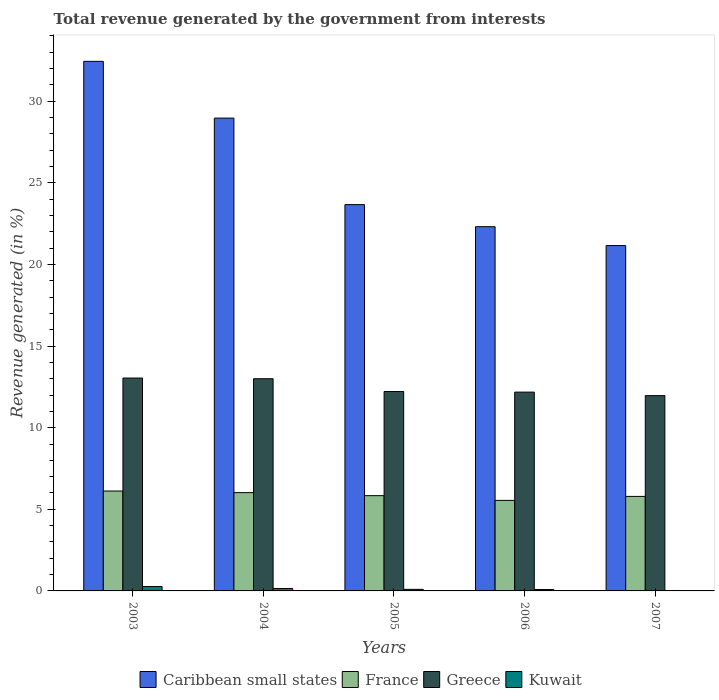How many different coloured bars are there?
Give a very brief answer. 4. How many groups of bars are there?
Provide a short and direct response. 5. Are the number of bars per tick equal to the number of legend labels?
Your response must be concise. Yes. Are the number of bars on each tick of the X-axis equal?
Provide a succinct answer. Yes. What is the label of the 1st group of bars from the left?
Ensure brevity in your answer.  2003. What is the total revenue generated in Greece in 2005?
Keep it short and to the point. 12.22. Across all years, what is the maximum total revenue generated in Caribbean small states?
Your answer should be very brief. 32.44. Across all years, what is the minimum total revenue generated in Caribbean small states?
Offer a very short reply. 21.16. What is the total total revenue generated in Kuwait in the graph?
Provide a short and direct response. 0.62. What is the difference between the total revenue generated in Greece in 2003 and that in 2004?
Keep it short and to the point. 0.04. What is the difference between the total revenue generated in France in 2003 and the total revenue generated in Greece in 2004?
Keep it short and to the point. -6.88. What is the average total revenue generated in Kuwait per year?
Keep it short and to the point. 0.12. In the year 2006, what is the difference between the total revenue generated in France and total revenue generated in Kuwait?
Provide a short and direct response. 5.46. What is the ratio of the total revenue generated in Greece in 2004 to that in 2006?
Provide a short and direct response. 1.07. Is the total revenue generated in Kuwait in 2004 less than that in 2006?
Give a very brief answer. No. Is the difference between the total revenue generated in France in 2004 and 2005 greater than the difference between the total revenue generated in Kuwait in 2004 and 2005?
Your response must be concise. Yes. What is the difference between the highest and the second highest total revenue generated in Kuwait?
Provide a short and direct response. 0.12. What is the difference between the highest and the lowest total revenue generated in France?
Your answer should be very brief. 0.57. In how many years, is the total revenue generated in Kuwait greater than the average total revenue generated in Kuwait taken over all years?
Your answer should be compact. 2. Is the sum of the total revenue generated in Greece in 2006 and 2007 greater than the maximum total revenue generated in France across all years?
Ensure brevity in your answer.  Yes. What does the 4th bar from the left in 2006 represents?
Provide a short and direct response. Kuwait. What does the 1st bar from the right in 2004 represents?
Your response must be concise. Kuwait. Is it the case that in every year, the sum of the total revenue generated in Greece and total revenue generated in France is greater than the total revenue generated in Kuwait?
Offer a terse response. Yes. Are all the bars in the graph horizontal?
Provide a succinct answer. No. What is the difference between two consecutive major ticks on the Y-axis?
Offer a very short reply. 5. Are the values on the major ticks of Y-axis written in scientific E-notation?
Keep it short and to the point. No. Does the graph contain any zero values?
Ensure brevity in your answer.  No. Does the graph contain grids?
Your answer should be very brief. No. Where does the legend appear in the graph?
Your response must be concise. Bottom center. How many legend labels are there?
Offer a very short reply. 4. What is the title of the graph?
Your answer should be compact. Total revenue generated by the government from interests. What is the label or title of the Y-axis?
Offer a terse response. Revenue generated (in %). What is the Revenue generated (in %) in Caribbean small states in 2003?
Your response must be concise. 32.44. What is the Revenue generated (in %) in France in 2003?
Provide a short and direct response. 6.12. What is the Revenue generated (in %) in Greece in 2003?
Keep it short and to the point. 13.04. What is the Revenue generated (in %) of Kuwait in 2003?
Provide a short and direct response. 0.27. What is the Revenue generated (in %) of Caribbean small states in 2004?
Offer a very short reply. 28.97. What is the Revenue generated (in %) in France in 2004?
Give a very brief answer. 6.02. What is the Revenue generated (in %) in Greece in 2004?
Your response must be concise. 13. What is the Revenue generated (in %) in Kuwait in 2004?
Provide a succinct answer. 0.15. What is the Revenue generated (in %) of Caribbean small states in 2005?
Make the answer very short. 23.67. What is the Revenue generated (in %) of France in 2005?
Provide a succinct answer. 5.84. What is the Revenue generated (in %) of Greece in 2005?
Offer a terse response. 12.22. What is the Revenue generated (in %) in Kuwait in 2005?
Ensure brevity in your answer.  0.1. What is the Revenue generated (in %) of Caribbean small states in 2006?
Provide a succinct answer. 22.31. What is the Revenue generated (in %) of France in 2006?
Your response must be concise. 5.55. What is the Revenue generated (in %) in Greece in 2006?
Keep it short and to the point. 12.18. What is the Revenue generated (in %) of Kuwait in 2006?
Offer a very short reply. 0.08. What is the Revenue generated (in %) of Caribbean small states in 2007?
Provide a succinct answer. 21.16. What is the Revenue generated (in %) in France in 2007?
Keep it short and to the point. 5.79. What is the Revenue generated (in %) in Greece in 2007?
Give a very brief answer. 11.96. What is the Revenue generated (in %) of Kuwait in 2007?
Make the answer very short. 0.03. Across all years, what is the maximum Revenue generated (in %) in Caribbean small states?
Your response must be concise. 32.44. Across all years, what is the maximum Revenue generated (in %) of France?
Your response must be concise. 6.12. Across all years, what is the maximum Revenue generated (in %) in Greece?
Provide a succinct answer. 13.04. Across all years, what is the maximum Revenue generated (in %) of Kuwait?
Your answer should be very brief. 0.27. Across all years, what is the minimum Revenue generated (in %) of Caribbean small states?
Provide a short and direct response. 21.16. Across all years, what is the minimum Revenue generated (in %) of France?
Keep it short and to the point. 5.55. Across all years, what is the minimum Revenue generated (in %) in Greece?
Keep it short and to the point. 11.96. Across all years, what is the minimum Revenue generated (in %) in Kuwait?
Provide a succinct answer. 0.03. What is the total Revenue generated (in %) in Caribbean small states in the graph?
Your response must be concise. 128.54. What is the total Revenue generated (in %) of France in the graph?
Your response must be concise. 29.31. What is the total Revenue generated (in %) of Greece in the graph?
Your response must be concise. 62.4. What is the total Revenue generated (in %) of Kuwait in the graph?
Keep it short and to the point. 0.62. What is the difference between the Revenue generated (in %) of Caribbean small states in 2003 and that in 2004?
Ensure brevity in your answer.  3.48. What is the difference between the Revenue generated (in %) in France in 2003 and that in 2004?
Offer a very short reply. 0.1. What is the difference between the Revenue generated (in %) in Greece in 2003 and that in 2004?
Your answer should be very brief. 0.04. What is the difference between the Revenue generated (in %) in Kuwait in 2003 and that in 2004?
Ensure brevity in your answer.  0.12. What is the difference between the Revenue generated (in %) of Caribbean small states in 2003 and that in 2005?
Offer a very short reply. 8.78. What is the difference between the Revenue generated (in %) of France in 2003 and that in 2005?
Make the answer very short. 0.28. What is the difference between the Revenue generated (in %) of Greece in 2003 and that in 2005?
Your answer should be very brief. 0.83. What is the difference between the Revenue generated (in %) of Kuwait in 2003 and that in 2005?
Your answer should be very brief. 0.17. What is the difference between the Revenue generated (in %) of Caribbean small states in 2003 and that in 2006?
Ensure brevity in your answer.  10.13. What is the difference between the Revenue generated (in %) of France in 2003 and that in 2006?
Keep it short and to the point. 0.57. What is the difference between the Revenue generated (in %) in Greece in 2003 and that in 2006?
Give a very brief answer. 0.86. What is the difference between the Revenue generated (in %) in Kuwait in 2003 and that in 2006?
Your response must be concise. 0.18. What is the difference between the Revenue generated (in %) in Caribbean small states in 2003 and that in 2007?
Your response must be concise. 11.29. What is the difference between the Revenue generated (in %) in France in 2003 and that in 2007?
Provide a succinct answer. 0.33. What is the difference between the Revenue generated (in %) of Greece in 2003 and that in 2007?
Your response must be concise. 1.08. What is the difference between the Revenue generated (in %) of Kuwait in 2003 and that in 2007?
Your response must be concise. 0.24. What is the difference between the Revenue generated (in %) in Caribbean small states in 2004 and that in 2005?
Give a very brief answer. 5.3. What is the difference between the Revenue generated (in %) of France in 2004 and that in 2005?
Keep it short and to the point. 0.19. What is the difference between the Revenue generated (in %) of Greece in 2004 and that in 2005?
Your response must be concise. 0.78. What is the difference between the Revenue generated (in %) in Kuwait in 2004 and that in 2005?
Keep it short and to the point. 0.05. What is the difference between the Revenue generated (in %) of Caribbean small states in 2004 and that in 2006?
Offer a very short reply. 6.65. What is the difference between the Revenue generated (in %) of France in 2004 and that in 2006?
Provide a short and direct response. 0.48. What is the difference between the Revenue generated (in %) of Greece in 2004 and that in 2006?
Your response must be concise. 0.82. What is the difference between the Revenue generated (in %) in Kuwait in 2004 and that in 2006?
Ensure brevity in your answer.  0.06. What is the difference between the Revenue generated (in %) of Caribbean small states in 2004 and that in 2007?
Provide a short and direct response. 7.81. What is the difference between the Revenue generated (in %) of France in 2004 and that in 2007?
Offer a terse response. 0.23. What is the difference between the Revenue generated (in %) in Greece in 2004 and that in 2007?
Your response must be concise. 1.04. What is the difference between the Revenue generated (in %) in Kuwait in 2004 and that in 2007?
Give a very brief answer. 0.12. What is the difference between the Revenue generated (in %) in Caribbean small states in 2005 and that in 2006?
Offer a terse response. 1.35. What is the difference between the Revenue generated (in %) in France in 2005 and that in 2006?
Give a very brief answer. 0.29. What is the difference between the Revenue generated (in %) of Greece in 2005 and that in 2006?
Your answer should be very brief. 0.04. What is the difference between the Revenue generated (in %) of Kuwait in 2005 and that in 2006?
Provide a short and direct response. 0.01. What is the difference between the Revenue generated (in %) of Caribbean small states in 2005 and that in 2007?
Make the answer very short. 2.51. What is the difference between the Revenue generated (in %) in France in 2005 and that in 2007?
Your answer should be very brief. 0.04. What is the difference between the Revenue generated (in %) in Greece in 2005 and that in 2007?
Provide a short and direct response. 0.25. What is the difference between the Revenue generated (in %) of Kuwait in 2005 and that in 2007?
Your answer should be compact. 0.07. What is the difference between the Revenue generated (in %) in Caribbean small states in 2006 and that in 2007?
Provide a succinct answer. 1.16. What is the difference between the Revenue generated (in %) in France in 2006 and that in 2007?
Give a very brief answer. -0.24. What is the difference between the Revenue generated (in %) of Greece in 2006 and that in 2007?
Your answer should be compact. 0.21. What is the difference between the Revenue generated (in %) of Kuwait in 2006 and that in 2007?
Give a very brief answer. 0.06. What is the difference between the Revenue generated (in %) in Caribbean small states in 2003 and the Revenue generated (in %) in France in 2004?
Provide a succinct answer. 26.42. What is the difference between the Revenue generated (in %) of Caribbean small states in 2003 and the Revenue generated (in %) of Greece in 2004?
Provide a short and direct response. 19.44. What is the difference between the Revenue generated (in %) of Caribbean small states in 2003 and the Revenue generated (in %) of Kuwait in 2004?
Your answer should be very brief. 32.29. What is the difference between the Revenue generated (in %) of France in 2003 and the Revenue generated (in %) of Greece in 2004?
Your answer should be very brief. -6.88. What is the difference between the Revenue generated (in %) in France in 2003 and the Revenue generated (in %) in Kuwait in 2004?
Make the answer very short. 5.97. What is the difference between the Revenue generated (in %) of Greece in 2003 and the Revenue generated (in %) of Kuwait in 2004?
Make the answer very short. 12.89. What is the difference between the Revenue generated (in %) in Caribbean small states in 2003 and the Revenue generated (in %) in France in 2005?
Your answer should be compact. 26.61. What is the difference between the Revenue generated (in %) of Caribbean small states in 2003 and the Revenue generated (in %) of Greece in 2005?
Offer a terse response. 20.23. What is the difference between the Revenue generated (in %) in Caribbean small states in 2003 and the Revenue generated (in %) in Kuwait in 2005?
Your answer should be very brief. 32.35. What is the difference between the Revenue generated (in %) in France in 2003 and the Revenue generated (in %) in Greece in 2005?
Provide a succinct answer. -6.09. What is the difference between the Revenue generated (in %) of France in 2003 and the Revenue generated (in %) of Kuwait in 2005?
Your response must be concise. 6.02. What is the difference between the Revenue generated (in %) of Greece in 2003 and the Revenue generated (in %) of Kuwait in 2005?
Offer a very short reply. 12.95. What is the difference between the Revenue generated (in %) of Caribbean small states in 2003 and the Revenue generated (in %) of France in 2006?
Your answer should be very brief. 26.9. What is the difference between the Revenue generated (in %) of Caribbean small states in 2003 and the Revenue generated (in %) of Greece in 2006?
Keep it short and to the point. 20.26. What is the difference between the Revenue generated (in %) of Caribbean small states in 2003 and the Revenue generated (in %) of Kuwait in 2006?
Provide a succinct answer. 32.36. What is the difference between the Revenue generated (in %) in France in 2003 and the Revenue generated (in %) in Greece in 2006?
Your answer should be compact. -6.06. What is the difference between the Revenue generated (in %) in France in 2003 and the Revenue generated (in %) in Kuwait in 2006?
Your answer should be very brief. 6.04. What is the difference between the Revenue generated (in %) of Greece in 2003 and the Revenue generated (in %) of Kuwait in 2006?
Provide a succinct answer. 12.96. What is the difference between the Revenue generated (in %) in Caribbean small states in 2003 and the Revenue generated (in %) in France in 2007?
Your response must be concise. 26.65. What is the difference between the Revenue generated (in %) in Caribbean small states in 2003 and the Revenue generated (in %) in Greece in 2007?
Ensure brevity in your answer.  20.48. What is the difference between the Revenue generated (in %) of Caribbean small states in 2003 and the Revenue generated (in %) of Kuwait in 2007?
Offer a very short reply. 32.42. What is the difference between the Revenue generated (in %) of France in 2003 and the Revenue generated (in %) of Greece in 2007?
Your answer should be very brief. -5.84. What is the difference between the Revenue generated (in %) in France in 2003 and the Revenue generated (in %) in Kuwait in 2007?
Give a very brief answer. 6.09. What is the difference between the Revenue generated (in %) in Greece in 2003 and the Revenue generated (in %) in Kuwait in 2007?
Provide a short and direct response. 13.01. What is the difference between the Revenue generated (in %) in Caribbean small states in 2004 and the Revenue generated (in %) in France in 2005?
Your answer should be very brief. 23.13. What is the difference between the Revenue generated (in %) of Caribbean small states in 2004 and the Revenue generated (in %) of Greece in 2005?
Ensure brevity in your answer.  16.75. What is the difference between the Revenue generated (in %) in Caribbean small states in 2004 and the Revenue generated (in %) in Kuwait in 2005?
Your answer should be very brief. 28.87. What is the difference between the Revenue generated (in %) in France in 2004 and the Revenue generated (in %) in Greece in 2005?
Your response must be concise. -6.19. What is the difference between the Revenue generated (in %) in France in 2004 and the Revenue generated (in %) in Kuwait in 2005?
Offer a terse response. 5.93. What is the difference between the Revenue generated (in %) of Greece in 2004 and the Revenue generated (in %) of Kuwait in 2005?
Keep it short and to the point. 12.9. What is the difference between the Revenue generated (in %) of Caribbean small states in 2004 and the Revenue generated (in %) of France in 2006?
Your answer should be very brief. 23.42. What is the difference between the Revenue generated (in %) in Caribbean small states in 2004 and the Revenue generated (in %) in Greece in 2006?
Ensure brevity in your answer.  16.79. What is the difference between the Revenue generated (in %) in Caribbean small states in 2004 and the Revenue generated (in %) in Kuwait in 2006?
Make the answer very short. 28.88. What is the difference between the Revenue generated (in %) in France in 2004 and the Revenue generated (in %) in Greece in 2006?
Ensure brevity in your answer.  -6.16. What is the difference between the Revenue generated (in %) of France in 2004 and the Revenue generated (in %) of Kuwait in 2006?
Give a very brief answer. 5.94. What is the difference between the Revenue generated (in %) in Greece in 2004 and the Revenue generated (in %) in Kuwait in 2006?
Keep it short and to the point. 12.91. What is the difference between the Revenue generated (in %) in Caribbean small states in 2004 and the Revenue generated (in %) in France in 2007?
Ensure brevity in your answer.  23.17. What is the difference between the Revenue generated (in %) in Caribbean small states in 2004 and the Revenue generated (in %) in Greece in 2007?
Provide a succinct answer. 17. What is the difference between the Revenue generated (in %) of Caribbean small states in 2004 and the Revenue generated (in %) of Kuwait in 2007?
Provide a short and direct response. 28.94. What is the difference between the Revenue generated (in %) in France in 2004 and the Revenue generated (in %) in Greece in 2007?
Your answer should be very brief. -5.94. What is the difference between the Revenue generated (in %) in France in 2004 and the Revenue generated (in %) in Kuwait in 2007?
Ensure brevity in your answer.  6. What is the difference between the Revenue generated (in %) in Greece in 2004 and the Revenue generated (in %) in Kuwait in 2007?
Give a very brief answer. 12.97. What is the difference between the Revenue generated (in %) in Caribbean small states in 2005 and the Revenue generated (in %) in France in 2006?
Keep it short and to the point. 18.12. What is the difference between the Revenue generated (in %) in Caribbean small states in 2005 and the Revenue generated (in %) in Greece in 2006?
Your response must be concise. 11.49. What is the difference between the Revenue generated (in %) in Caribbean small states in 2005 and the Revenue generated (in %) in Kuwait in 2006?
Offer a very short reply. 23.58. What is the difference between the Revenue generated (in %) in France in 2005 and the Revenue generated (in %) in Greece in 2006?
Offer a very short reply. -6.34. What is the difference between the Revenue generated (in %) in France in 2005 and the Revenue generated (in %) in Kuwait in 2006?
Your answer should be compact. 5.75. What is the difference between the Revenue generated (in %) in Greece in 2005 and the Revenue generated (in %) in Kuwait in 2006?
Keep it short and to the point. 12.13. What is the difference between the Revenue generated (in %) in Caribbean small states in 2005 and the Revenue generated (in %) in France in 2007?
Provide a short and direct response. 17.87. What is the difference between the Revenue generated (in %) in Caribbean small states in 2005 and the Revenue generated (in %) in Greece in 2007?
Keep it short and to the point. 11.7. What is the difference between the Revenue generated (in %) in Caribbean small states in 2005 and the Revenue generated (in %) in Kuwait in 2007?
Ensure brevity in your answer.  23.64. What is the difference between the Revenue generated (in %) in France in 2005 and the Revenue generated (in %) in Greece in 2007?
Provide a succinct answer. -6.13. What is the difference between the Revenue generated (in %) of France in 2005 and the Revenue generated (in %) of Kuwait in 2007?
Your response must be concise. 5.81. What is the difference between the Revenue generated (in %) of Greece in 2005 and the Revenue generated (in %) of Kuwait in 2007?
Keep it short and to the point. 12.19. What is the difference between the Revenue generated (in %) of Caribbean small states in 2006 and the Revenue generated (in %) of France in 2007?
Your answer should be very brief. 16.52. What is the difference between the Revenue generated (in %) of Caribbean small states in 2006 and the Revenue generated (in %) of Greece in 2007?
Give a very brief answer. 10.35. What is the difference between the Revenue generated (in %) of Caribbean small states in 2006 and the Revenue generated (in %) of Kuwait in 2007?
Provide a succinct answer. 22.29. What is the difference between the Revenue generated (in %) in France in 2006 and the Revenue generated (in %) in Greece in 2007?
Offer a terse response. -6.42. What is the difference between the Revenue generated (in %) in France in 2006 and the Revenue generated (in %) in Kuwait in 2007?
Your response must be concise. 5.52. What is the difference between the Revenue generated (in %) in Greece in 2006 and the Revenue generated (in %) in Kuwait in 2007?
Make the answer very short. 12.15. What is the average Revenue generated (in %) in Caribbean small states per year?
Provide a succinct answer. 25.71. What is the average Revenue generated (in %) of France per year?
Ensure brevity in your answer.  5.86. What is the average Revenue generated (in %) in Greece per year?
Provide a short and direct response. 12.48. What is the average Revenue generated (in %) in Kuwait per year?
Provide a succinct answer. 0.12. In the year 2003, what is the difference between the Revenue generated (in %) in Caribbean small states and Revenue generated (in %) in France?
Ensure brevity in your answer.  26.32. In the year 2003, what is the difference between the Revenue generated (in %) in Caribbean small states and Revenue generated (in %) in Greece?
Make the answer very short. 19.4. In the year 2003, what is the difference between the Revenue generated (in %) of Caribbean small states and Revenue generated (in %) of Kuwait?
Provide a succinct answer. 32.17. In the year 2003, what is the difference between the Revenue generated (in %) in France and Revenue generated (in %) in Greece?
Offer a terse response. -6.92. In the year 2003, what is the difference between the Revenue generated (in %) in France and Revenue generated (in %) in Kuwait?
Offer a very short reply. 5.85. In the year 2003, what is the difference between the Revenue generated (in %) of Greece and Revenue generated (in %) of Kuwait?
Provide a succinct answer. 12.77. In the year 2004, what is the difference between the Revenue generated (in %) of Caribbean small states and Revenue generated (in %) of France?
Keep it short and to the point. 22.94. In the year 2004, what is the difference between the Revenue generated (in %) in Caribbean small states and Revenue generated (in %) in Greece?
Offer a very short reply. 15.97. In the year 2004, what is the difference between the Revenue generated (in %) in Caribbean small states and Revenue generated (in %) in Kuwait?
Keep it short and to the point. 28.82. In the year 2004, what is the difference between the Revenue generated (in %) of France and Revenue generated (in %) of Greece?
Provide a succinct answer. -6.98. In the year 2004, what is the difference between the Revenue generated (in %) of France and Revenue generated (in %) of Kuwait?
Offer a terse response. 5.87. In the year 2004, what is the difference between the Revenue generated (in %) of Greece and Revenue generated (in %) of Kuwait?
Your response must be concise. 12.85. In the year 2005, what is the difference between the Revenue generated (in %) in Caribbean small states and Revenue generated (in %) in France?
Provide a short and direct response. 17.83. In the year 2005, what is the difference between the Revenue generated (in %) in Caribbean small states and Revenue generated (in %) in Greece?
Give a very brief answer. 11.45. In the year 2005, what is the difference between the Revenue generated (in %) in Caribbean small states and Revenue generated (in %) in Kuwait?
Make the answer very short. 23.57. In the year 2005, what is the difference between the Revenue generated (in %) of France and Revenue generated (in %) of Greece?
Offer a very short reply. -6.38. In the year 2005, what is the difference between the Revenue generated (in %) of France and Revenue generated (in %) of Kuwait?
Keep it short and to the point. 5.74. In the year 2005, what is the difference between the Revenue generated (in %) of Greece and Revenue generated (in %) of Kuwait?
Provide a short and direct response. 12.12. In the year 2006, what is the difference between the Revenue generated (in %) of Caribbean small states and Revenue generated (in %) of France?
Your answer should be very brief. 16.77. In the year 2006, what is the difference between the Revenue generated (in %) in Caribbean small states and Revenue generated (in %) in Greece?
Your answer should be compact. 10.13. In the year 2006, what is the difference between the Revenue generated (in %) in Caribbean small states and Revenue generated (in %) in Kuwait?
Keep it short and to the point. 22.23. In the year 2006, what is the difference between the Revenue generated (in %) of France and Revenue generated (in %) of Greece?
Give a very brief answer. -6.63. In the year 2006, what is the difference between the Revenue generated (in %) in France and Revenue generated (in %) in Kuwait?
Provide a succinct answer. 5.46. In the year 2006, what is the difference between the Revenue generated (in %) of Greece and Revenue generated (in %) of Kuwait?
Your answer should be compact. 12.09. In the year 2007, what is the difference between the Revenue generated (in %) of Caribbean small states and Revenue generated (in %) of France?
Keep it short and to the point. 15.37. In the year 2007, what is the difference between the Revenue generated (in %) in Caribbean small states and Revenue generated (in %) in Greece?
Provide a short and direct response. 9.19. In the year 2007, what is the difference between the Revenue generated (in %) in Caribbean small states and Revenue generated (in %) in Kuwait?
Your response must be concise. 21.13. In the year 2007, what is the difference between the Revenue generated (in %) in France and Revenue generated (in %) in Greece?
Offer a very short reply. -6.17. In the year 2007, what is the difference between the Revenue generated (in %) of France and Revenue generated (in %) of Kuwait?
Give a very brief answer. 5.76. In the year 2007, what is the difference between the Revenue generated (in %) in Greece and Revenue generated (in %) in Kuwait?
Your answer should be compact. 11.94. What is the ratio of the Revenue generated (in %) of Caribbean small states in 2003 to that in 2004?
Offer a terse response. 1.12. What is the ratio of the Revenue generated (in %) in France in 2003 to that in 2004?
Provide a succinct answer. 1.02. What is the ratio of the Revenue generated (in %) in Kuwait in 2003 to that in 2004?
Provide a succinct answer. 1.8. What is the ratio of the Revenue generated (in %) of Caribbean small states in 2003 to that in 2005?
Your response must be concise. 1.37. What is the ratio of the Revenue generated (in %) of France in 2003 to that in 2005?
Ensure brevity in your answer.  1.05. What is the ratio of the Revenue generated (in %) in Greece in 2003 to that in 2005?
Offer a very short reply. 1.07. What is the ratio of the Revenue generated (in %) in Kuwait in 2003 to that in 2005?
Your answer should be very brief. 2.79. What is the ratio of the Revenue generated (in %) of Caribbean small states in 2003 to that in 2006?
Offer a terse response. 1.45. What is the ratio of the Revenue generated (in %) of France in 2003 to that in 2006?
Give a very brief answer. 1.1. What is the ratio of the Revenue generated (in %) of Greece in 2003 to that in 2006?
Your answer should be compact. 1.07. What is the ratio of the Revenue generated (in %) of Kuwait in 2003 to that in 2006?
Offer a very short reply. 3.15. What is the ratio of the Revenue generated (in %) of Caribbean small states in 2003 to that in 2007?
Your answer should be compact. 1.53. What is the ratio of the Revenue generated (in %) in France in 2003 to that in 2007?
Provide a short and direct response. 1.06. What is the ratio of the Revenue generated (in %) of Greece in 2003 to that in 2007?
Offer a very short reply. 1.09. What is the ratio of the Revenue generated (in %) of Kuwait in 2003 to that in 2007?
Offer a very short reply. 10.04. What is the ratio of the Revenue generated (in %) in Caribbean small states in 2004 to that in 2005?
Ensure brevity in your answer.  1.22. What is the ratio of the Revenue generated (in %) in France in 2004 to that in 2005?
Give a very brief answer. 1.03. What is the ratio of the Revenue generated (in %) in Greece in 2004 to that in 2005?
Offer a terse response. 1.06. What is the ratio of the Revenue generated (in %) in Kuwait in 2004 to that in 2005?
Your answer should be very brief. 1.55. What is the ratio of the Revenue generated (in %) of Caribbean small states in 2004 to that in 2006?
Offer a very short reply. 1.3. What is the ratio of the Revenue generated (in %) of France in 2004 to that in 2006?
Give a very brief answer. 1.09. What is the ratio of the Revenue generated (in %) of Greece in 2004 to that in 2006?
Your response must be concise. 1.07. What is the ratio of the Revenue generated (in %) in Kuwait in 2004 to that in 2006?
Provide a succinct answer. 1.75. What is the ratio of the Revenue generated (in %) of Caribbean small states in 2004 to that in 2007?
Your answer should be compact. 1.37. What is the ratio of the Revenue generated (in %) in France in 2004 to that in 2007?
Your answer should be compact. 1.04. What is the ratio of the Revenue generated (in %) in Greece in 2004 to that in 2007?
Your answer should be compact. 1.09. What is the ratio of the Revenue generated (in %) in Kuwait in 2004 to that in 2007?
Offer a very short reply. 5.58. What is the ratio of the Revenue generated (in %) of Caribbean small states in 2005 to that in 2006?
Offer a very short reply. 1.06. What is the ratio of the Revenue generated (in %) of France in 2005 to that in 2006?
Provide a succinct answer. 1.05. What is the ratio of the Revenue generated (in %) of Kuwait in 2005 to that in 2006?
Provide a succinct answer. 1.13. What is the ratio of the Revenue generated (in %) of Caribbean small states in 2005 to that in 2007?
Give a very brief answer. 1.12. What is the ratio of the Revenue generated (in %) in France in 2005 to that in 2007?
Provide a succinct answer. 1.01. What is the ratio of the Revenue generated (in %) in Greece in 2005 to that in 2007?
Your answer should be very brief. 1.02. What is the ratio of the Revenue generated (in %) in Kuwait in 2005 to that in 2007?
Provide a short and direct response. 3.6. What is the ratio of the Revenue generated (in %) in Caribbean small states in 2006 to that in 2007?
Your response must be concise. 1.05. What is the ratio of the Revenue generated (in %) of France in 2006 to that in 2007?
Your answer should be very brief. 0.96. What is the ratio of the Revenue generated (in %) in Kuwait in 2006 to that in 2007?
Keep it short and to the point. 3.18. What is the difference between the highest and the second highest Revenue generated (in %) in Caribbean small states?
Provide a succinct answer. 3.48. What is the difference between the highest and the second highest Revenue generated (in %) in France?
Your answer should be compact. 0.1. What is the difference between the highest and the second highest Revenue generated (in %) of Greece?
Offer a terse response. 0.04. What is the difference between the highest and the second highest Revenue generated (in %) in Kuwait?
Ensure brevity in your answer.  0.12. What is the difference between the highest and the lowest Revenue generated (in %) in Caribbean small states?
Your answer should be compact. 11.29. What is the difference between the highest and the lowest Revenue generated (in %) in France?
Your response must be concise. 0.57. What is the difference between the highest and the lowest Revenue generated (in %) in Greece?
Keep it short and to the point. 1.08. What is the difference between the highest and the lowest Revenue generated (in %) of Kuwait?
Offer a very short reply. 0.24. 